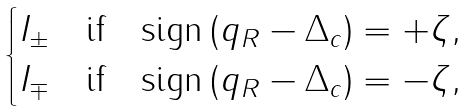Convert formula to latex. <formula><loc_0><loc_0><loc_500><loc_500>\begin{cases} I _ { \pm } & \text {if} \quad \text {sign} \left ( q _ { R } - \Delta _ { c } \right ) = + \zeta , \\ I _ { \mp } & \text {if} \quad \text {sign} \left ( q _ { R } - \Delta _ { c } \right ) = - \zeta , \end{cases}</formula> 